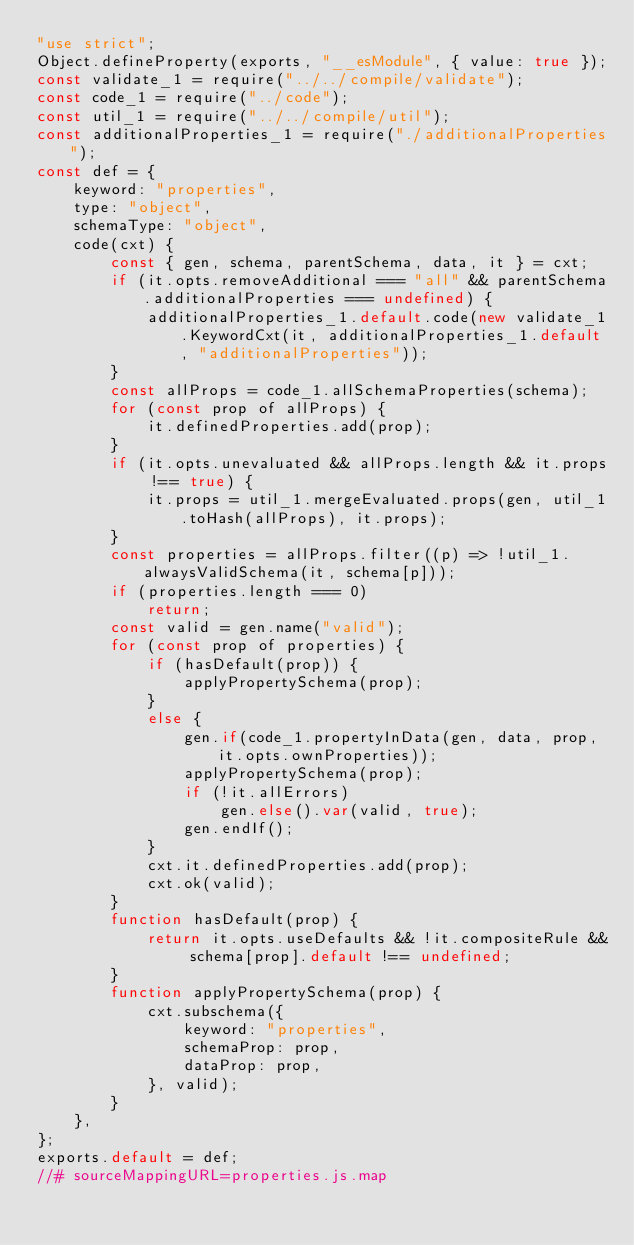<code> <loc_0><loc_0><loc_500><loc_500><_JavaScript_>"use strict";
Object.defineProperty(exports, "__esModule", { value: true });
const validate_1 = require("../../compile/validate");
const code_1 = require("../code");
const util_1 = require("../../compile/util");
const additionalProperties_1 = require("./additionalProperties");
const def = {
    keyword: "properties",
    type: "object",
    schemaType: "object",
    code(cxt) {
        const { gen, schema, parentSchema, data, it } = cxt;
        if (it.opts.removeAdditional === "all" && parentSchema.additionalProperties === undefined) {
            additionalProperties_1.default.code(new validate_1.KeywordCxt(it, additionalProperties_1.default, "additionalProperties"));
        }
        const allProps = code_1.allSchemaProperties(schema);
        for (const prop of allProps) {
            it.definedProperties.add(prop);
        }
        if (it.opts.unevaluated && allProps.length && it.props !== true) {
            it.props = util_1.mergeEvaluated.props(gen, util_1.toHash(allProps), it.props);
        }
        const properties = allProps.filter((p) => !util_1.alwaysValidSchema(it, schema[p]));
        if (properties.length === 0)
            return;
        const valid = gen.name("valid");
        for (const prop of properties) {
            if (hasDefault(prop)) {
                applyPropertySchema(prop);
            }
            else {
                gen.if(code_1.propertyInData(gen, data, prop, it.opts.ownProperties));
                applyPropertySchema(prop);
                if (!it.allErrors)
                    gen.else().var(valid, true);
                gen.endIf();
            }
            cxt.it.definedProperties.add(prop);
            cxt.ok(valid);
        }
        function hasDefault(prop) {
            return it.opts.useDefaults && !it.compositeRule && schema[prop].default !== undefined;
        }
        function applyPropertySchema(prop) {
            cxt.subschema({
                keyword: "properties",
                schemaProp: prop,
                dataProp: prop,
            }, valid);
        }
    },
};
exports.default = def;
//# sourceMappingURL=properties.js.map</code> 